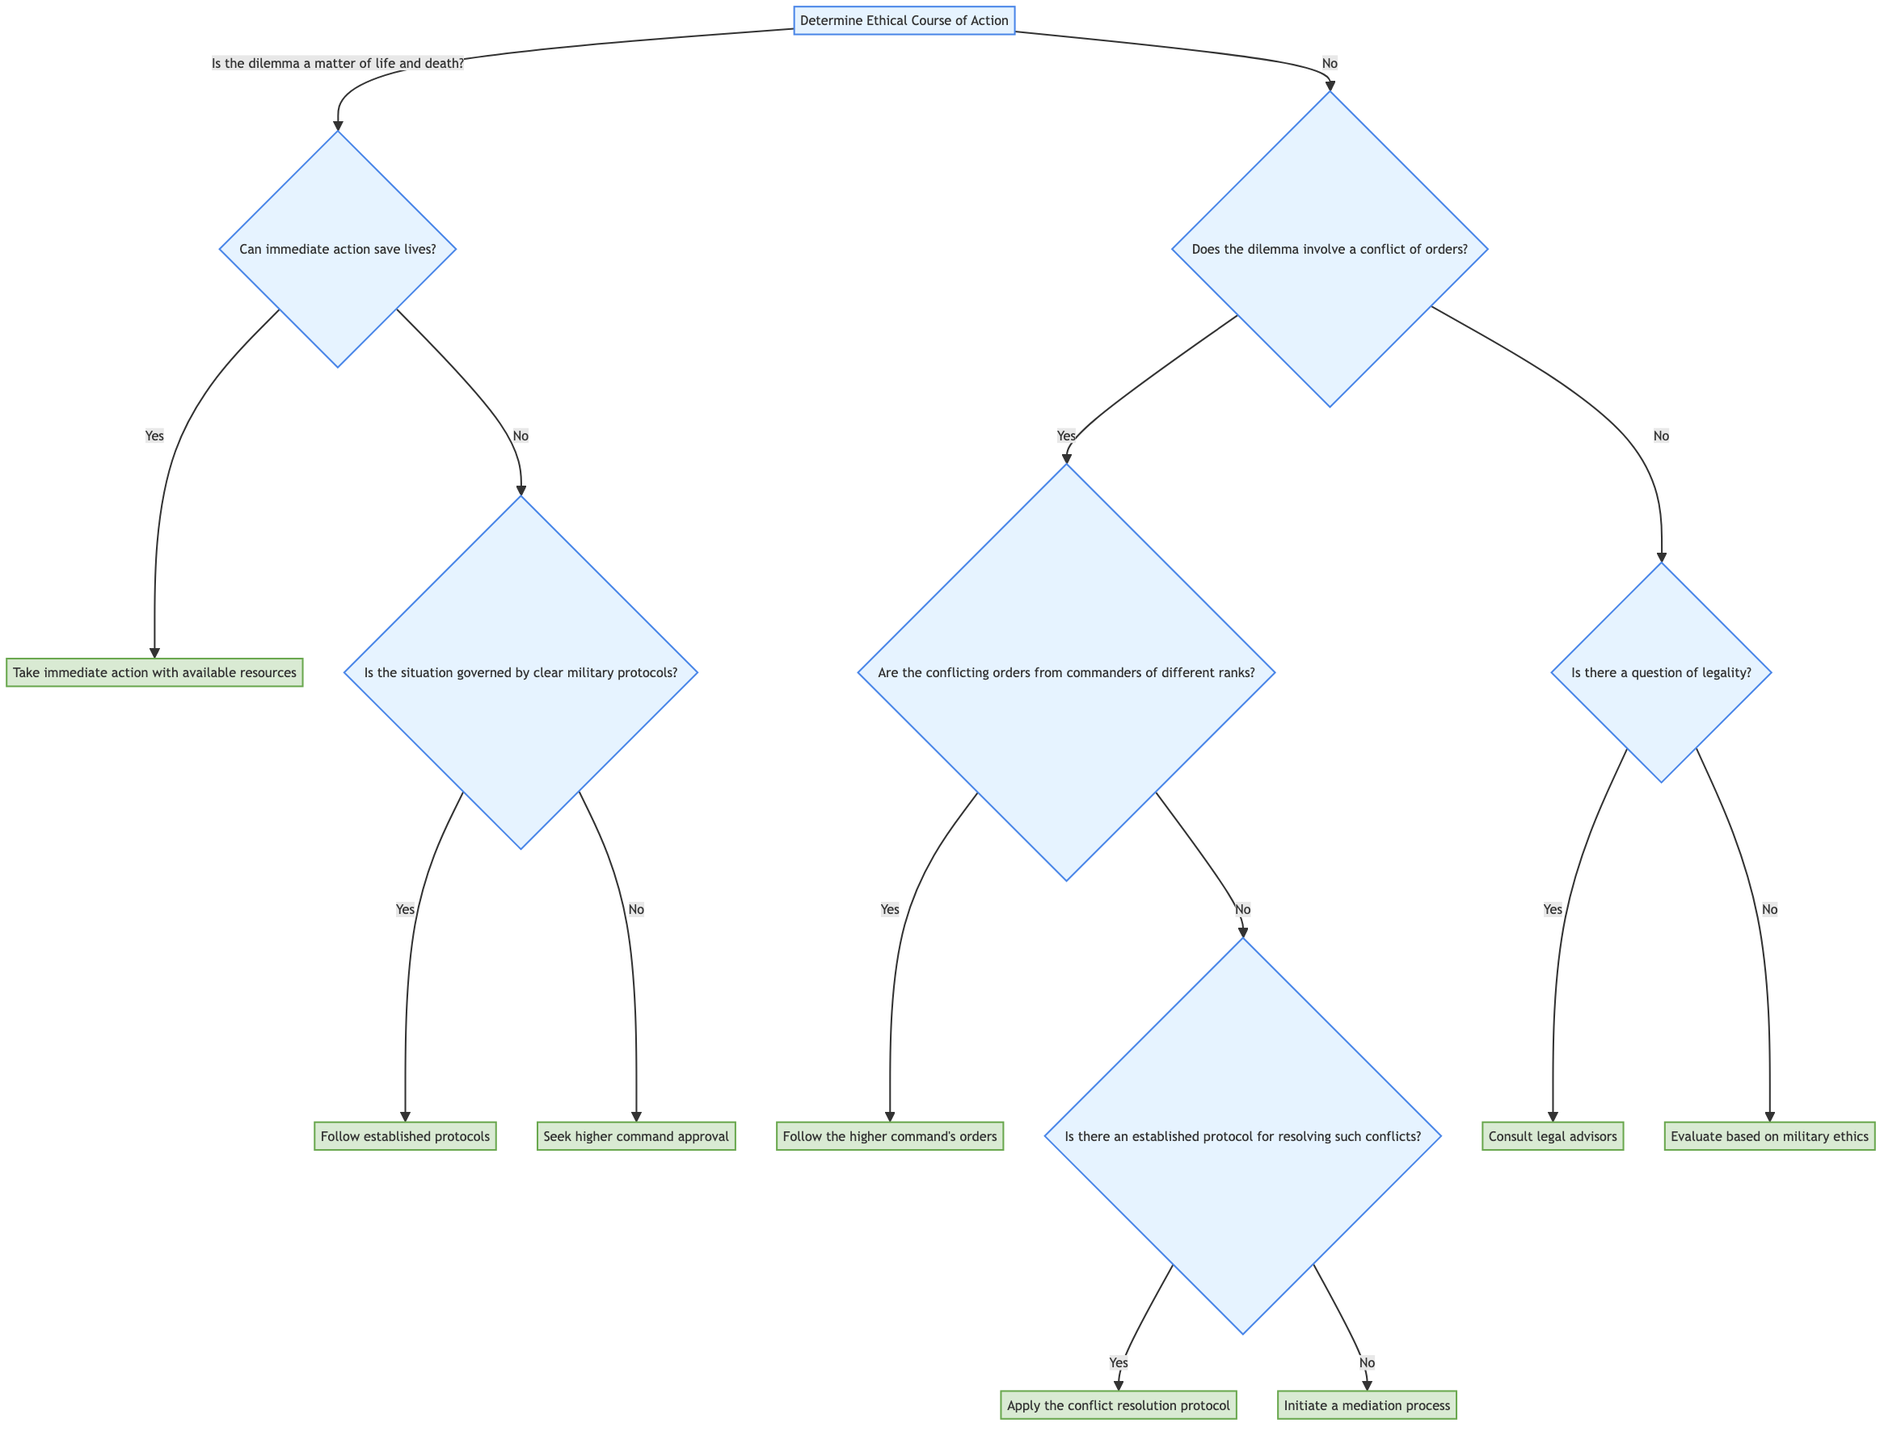What is the main decision point in the diagram? The main decision point is to determine the ethical course of action. This is represented by the root node which poses the initial inquiry about the nature of the dilemma.
Answer: Determine ethical course of action How many actions are listed in the diagram? There are six distinct actions enumerated within the diagram, each corresponding to different potential resolutions of ethical dilemmas.
Answer: 6 What happens if immediate action cannot save lives? If immediate action cannot save lives, the decision subsequently branches to determining if the situation is governed by clear military protocols.
Answer: Follow established protocols What should be done if there's a conflict of orders from commanders of different ranks? In this case, the higher command's orders should be followed. The diagram illustrates this as the appropriate course of action under such circumstances.
Answer: Follow the higher command's orders What action is taken if there is a question of legality? When legality is in question, consulting legal advisors is the designated course of action as per the decision tree structure.
Answer: Consult legal advisors What process is initiated if there is no established protocol for resolving conflicting orders? If no established protocol exists to resolve conflicting orders, the diagram indicates that a mediation process should be initiated to tackle the conflict.
Answer: Initiate a mediation process How does the diagram suggest evaluating the situation if there is no issue of legality? The diagram suggests evaluating the situation based on military ethics, using principles like integrity, duty, and honor to guide the decision when legality is not a concern.
Answer: Evaluate based on military ethics 